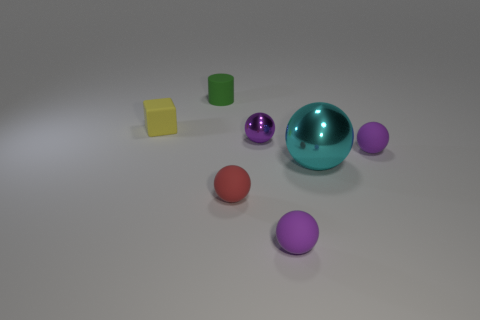What is the size of the object that is behind the yellow object?
Your answer should be very brief. Small. The large metallic object is what shape?
Offer a very short reply. Sphere. Do the metal thing that is behind the cyan thing and the matte object behind the tiny matte cube have the same size?
Offer a terse response. Yes. What is the size of the metal sphere that is right of the small purple rubber object in front of the purple rubber ball that is behind the red thing?
Give a very brief answer. Large. The thing that is left of the tiny object that is behind the rubber thing that is on the left side of the matte cylinder is what shape?
Your response must be concise. Cube. There is a object behind the cube; what is its shape?
Provide a succinct answer. Cylinder. Do the big object and the object that is behind the tiny yellow block have the same material?
Provide a succinct answer. No. What number of other objects are there of the same shape as the yellow matte object?
Your answer should be very brief. 0. Does the tiny metallic thing have the same color as the matte thing in front of the red object?
Make the answer very short. Yes. There is a thing that is on the left side of the tiny rubber object that is behind the tiny cube; what shape is it?
Your answer should be very brief. Cube. 